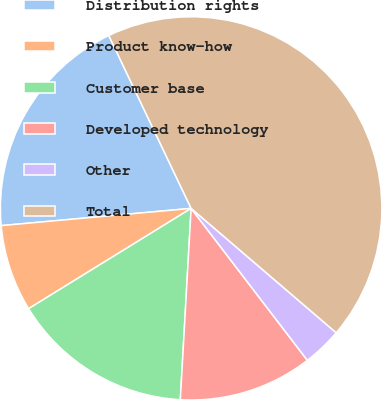<chart> <loc_0><loc_0><loc_500><loc_500><pie_chart><fcel>Distribution rights<fcel>Product know-how<fcel>Customer base<fcel>Developed technology<fcel>Other<fcel>Total<nl><fcel>19.33%<fcel>7.33%<fcel>15.33%<fcel>11.33%<fcel>3.33%<fcel>43.34%<nl></chart> 